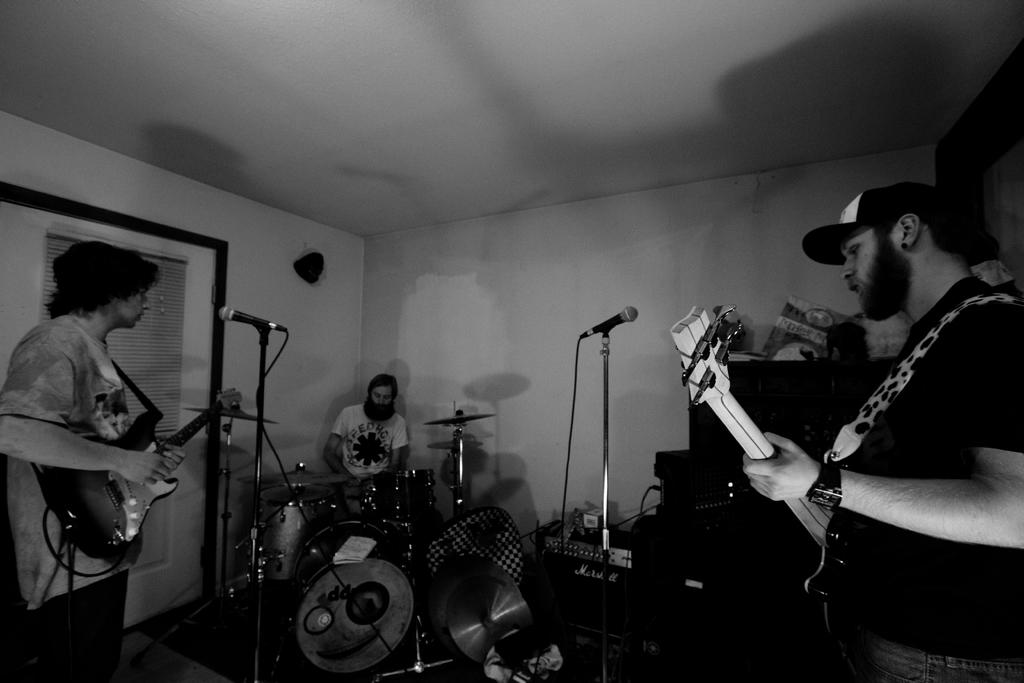What are the two men in the image doing? The two men in the image are holding guitars and playing them. What is the seated man in the image doing? The seated man in the image is playing drums. What can be seen in front of the musicians in the image? There are microphones in front of the musicians in the image. What type of border can be seen around the drum set in the image? There is no border around the drum set in the image; it is not mentioned in the provided facts. 